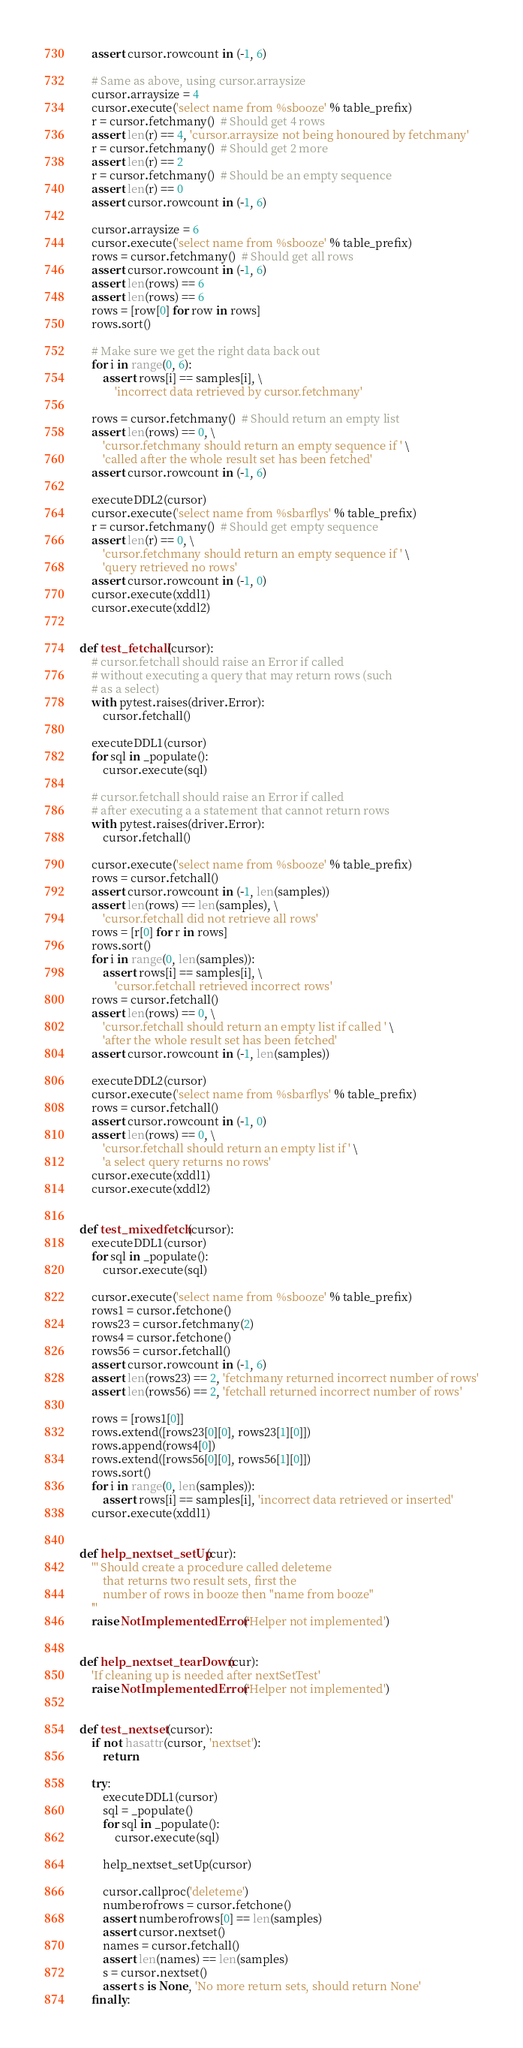<code> <loc_0><loc_0><loc_500><loc_500><_Python_>    assert cursor.rowcount in (-1, 6)

    # Same as above, using cursor.arraysize
    cursor.arraysize = 4
    cursor.execute('select name from %sbooze' % table_prefix)
    r = cursor.fetchmany()  # Should get 4 rows
    assert len(r) == 4, 'cursor.arraysize not being honoured by fetchmany'
    r = cursor.fetchmany()  # Should get 2 more
    assert len(r) == 2
    r = cursor.fetchmany()  # Should be an empty sequence
    assert len(r) == 0
    assert cursor.rowcount in (-1, 6)

    cursor.arraysize = 6
    cursor.execute('select name from %sbooze' % table_prefix)
    rows = cursor.fetchmany()  # Should get all rows
    assert cursor.rowcount in (-1, 6)
    assert len(rows) == 6
    assert len(rows) == 6
    rows = [row[0] for row in rows]
    rows.sort()

    # Make sure we get the right data back out
    for i in range(0, 6):
        assert rows[i] == samples[i], \
            'incorrect data retrieved by cursor.fetchmany'

    rows = cursor.fetchmany()  # Should return an empty list
    assert len(rows) == 0, \
        'cursor.fetchmany should return an empty sequence if ' \
        'called after the whole result set has been fetched'
    assert cursor.rowcount in (-1, 6)

    executeDDL2(cursor)
    cursor.execute('select name from %sbarflys' % table_prefix)
    r = cursor.fetchmany()  # Should get empty sequence
    assert len(r) == 0, \
        'cursor.fetchmany should return an empty sequence if ' \
        'query retrieved no rows'
    assert cursor.rowcount in (-1, 0)
    cursor.execute(xddl1)
    cursor.execute(xddl2)


def test_fetchall(cursor):
    # cursor.fetchall should raise an Error if called
    # without executing a query that may return rows (such
    # as a select)
    with pytest.raises(driver.Error):
        cursor.fetchall()

    executeDDL1(cursor)
    for sql in _populate():
        cursor.execute(sql)

    # cursor.fetchall should raise an Error if called
    # after executing a a statement that cannot return rows
    with pytest.raises(driver.Error):
        cursor.fetchall()

    cursor.execute('select name from %sbooze' % table_prefix)
    rows = cursor.fetchall()
    assert cursor.rowcount in (-1, len(samples))
    assert len(rows) == len(samples), \
        'cursor.fetchall did not retrieve all rows'
    rows = [r[0] for r in rows]
    rows.sort()
    for i in range(0, len(samples)):
        assert rows[i] == samples[i], \
            'cursor.fetchall retrieved incorrect rows'
    rows = cursor.fetchall()
    assert len(rows) == 0, \
        'cursor.fetchall should return an empty list if called ' \
        'after the whole result set has been fetched'
    assert cursor.rowcount in (-1, len(samples))

    executeDDL2(cursor)
    cursor.execute('select name from %sbarflys' % table_prefix)
    rows = cursor.fetchall()
    assert cursor.rowcount in (-1, 0)
    assert len(rows) == 0, \
        'cursor.fetchall should return an empty list if ' \
        'a select query returns no rows'
    cursor.execute(xddl1)
    cursor.execute(xddl2)


def test_mixedfetch(cursor):
    executeDDL1(cursor)
    for sql in _populate():
        cursor.execute(sql)

    cursor.execute('select name from %sbooze' % table_prefix)
    rows1 = cursor.fetchone()
    rows23 = cursor.fetchmany(2)
    rows4 = cursor.fetchone()
    rows56 = cursor.fetchall()
    assert cursor.rowcount in (-1, 6)
    assert len(rows23) == 2, 'fetchmany returned incorrect number of rows'
    assert len(rows56) == 2, 'fetchall returned incorrect number of rows'

    rows = [rows1[0]]
    rows.extend([rows23[0][0], rows23[1][0]])
    rows.append(rows4[0])
    rows.extend([rows56[0][0], rows56[1][0]])
    rows.sort()
    for i in range(0, len(samples)):
        assert rows[i] == samples[i], 'incorrect data retrieved or inserted'
    cursor.execute(xddl1)


def help_nextset_setUp(cur):
    ''' Should create a procedure called deleteme
        that returns two result sets, first the
        number of rows in booze then "name from booze"
    '''
    raise NotImplementedError('Helper not implemented')


def help_nextset_tearDown(cur):
    'If cleaning up is needed after nextSetTest'
    raise NotImplementedError('Helper not implemented')


def test_nextset(cursor):
    if not hasattr(cursor, 'nextset'):
        return

    try:
        executeDDL1(cursor)
        sql = _populate()
        for sql in _populate():
            cursor.execute(sql)

        help_nextset_setUp(cursor)

        cursor.callproc('deleteme')
        numberofrows = cursor.fetchone()
        assert numberofrows[0] == len(samples)
        assert cursor.nextset()
        names = cursor.fetchall()
        assert len(names) == len(samples)
        s = cursor.nextset()
        assert s is None, 'No more return sets, should return None'
    finally:</code> 